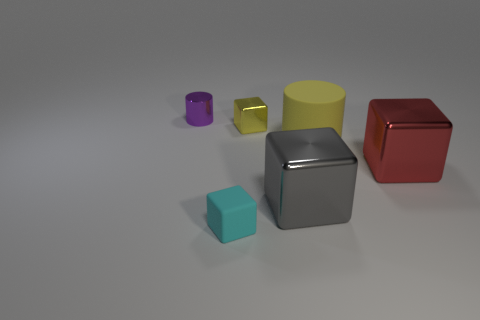Add 2 cyan matte things. How many objects exist? 8 Subtract all cylinders. How many objects are left? 4 Subtract 0 green spheres. How many objects are left? 6 Subtract all red things. Subtract all small cyan things. How many objects are left? 4 Add 2 large gray things. How many large gray things are left? 3 Add 4 small objects. How many small objects exist? 7 